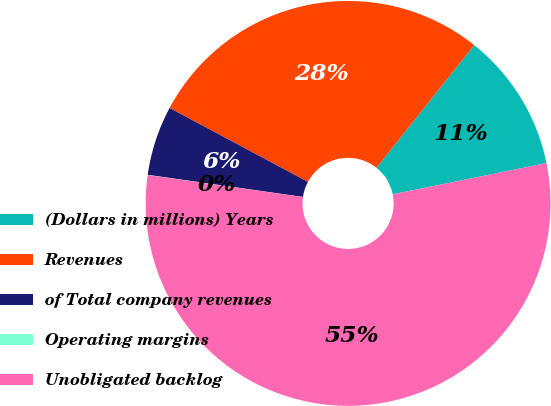Convert chart to OTSL. <chart><loc_0><loc_0><loc_500><loc_500><pie_chart><fcel>(Dollars in millions) Years<fcel>Revenues<fcel>of Total company revenues<fcel>Operating margins<fcel>Unobligated backlog<nl><fcel>11.1%<fcel>27.9%<fcel>5.56%<fcel>0.02%<fcel>55.42%<nl></chart> 